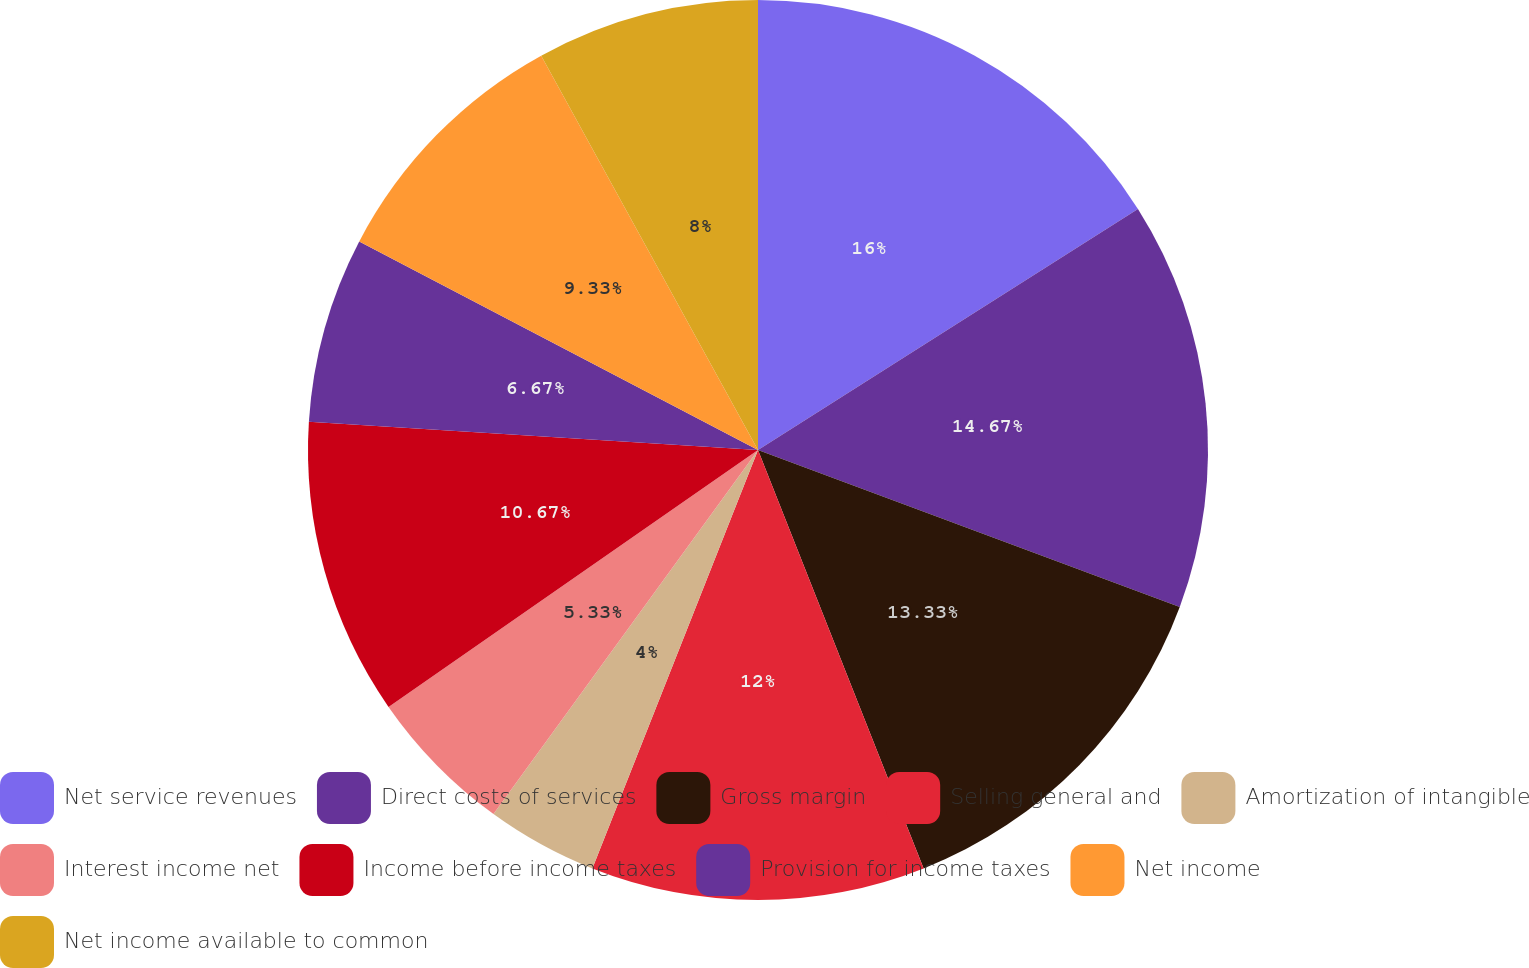Convert chart to OTSL. <chart><loc_0><loc_0><loc_500><loc_500><pie_chart><fcel>Net service revenues<fcel>Direct costs of services<fcel>Gross margin<fcel>Selling general and<fcel>Amortization of intangible<fcel>Interest income net<fcel>Income before income taxes<fcel>Provision for income taxes<fcel>Net income<fcel>Net income available to common<nl><fcel>16.0%<fcel>14.67%<fcel>13.33%<fcel>12.0%<fcel>4.0%<fcel>5.33%<fcel>10.67%<fcel>6.67%<fcel>9.33%<fcel>8.0%<nl></chart> 